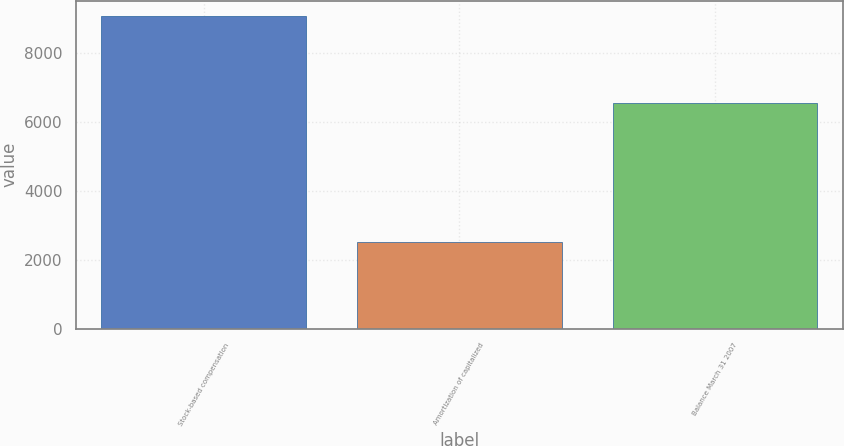Convert chart to OTSL. <chart><loc_0><loc_0><loc_500><loc_500><bar_chart><fcel>Stock-based compensation<fcel>Amortization of capitalized<fcel>Balance March 31 2007<nl><fcel>9069<fcel>2503<fcel>6566<nl></chart> 